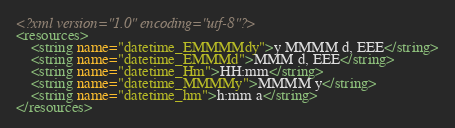<code> <loc_0><loc_0><loc_500><loc_500><_XML_><?xml version="1.0" encoding="utf-8"?>
<resources>
    <string name="datetime_EMMMMdy">y MMMM d, EEE</string>
    <string name="datetime_EMMMd">MMM d, EEE</string>
    <string name="datetime_Hm">HH:mm</string>
    <string name="datetime_MMMMy">MMMM y</string>
    <string name="datetime_hm">h:mm a</string>
</resources></code> 